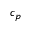Convert formula to latex. <formula><loc_0><loc_0><loc_500><loc_500>c _ { p }</formula> 